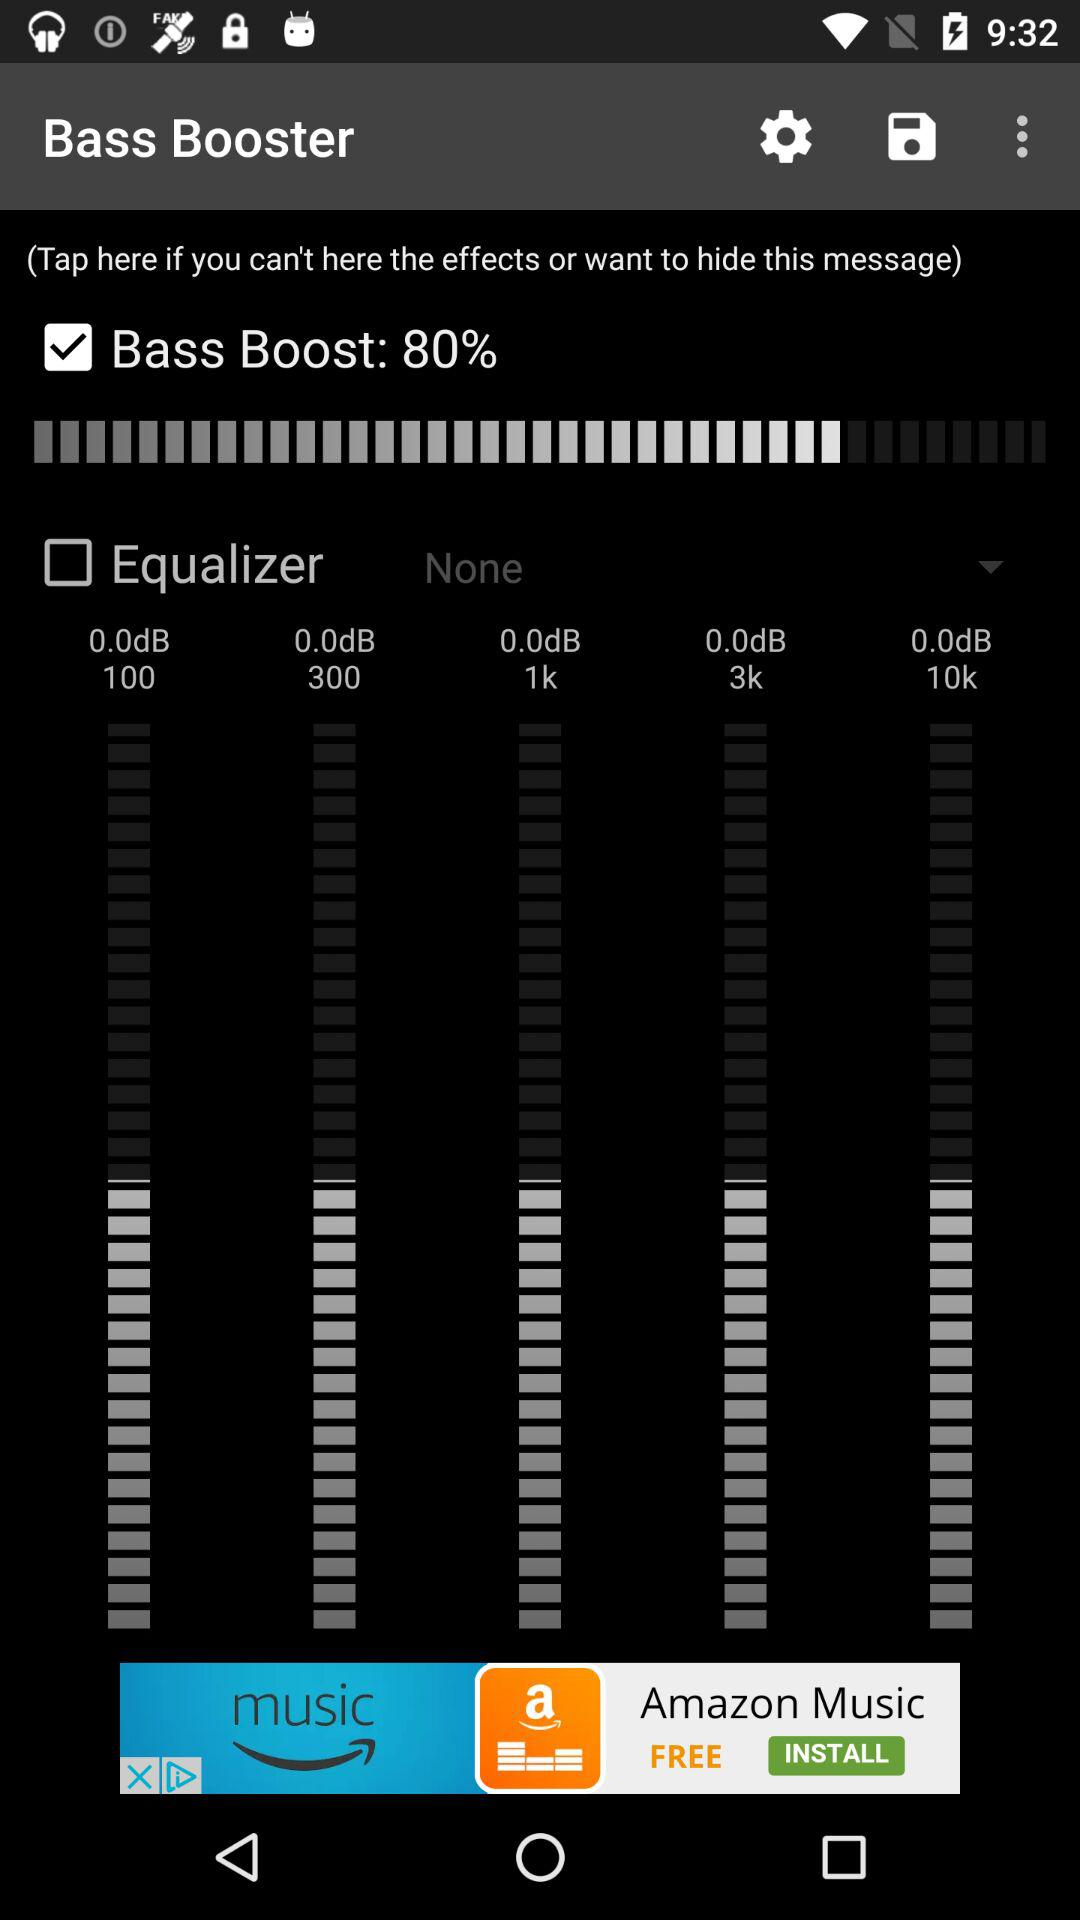How many bands are there on the equalizer?
Answer the question using a single word or phrase. 5 